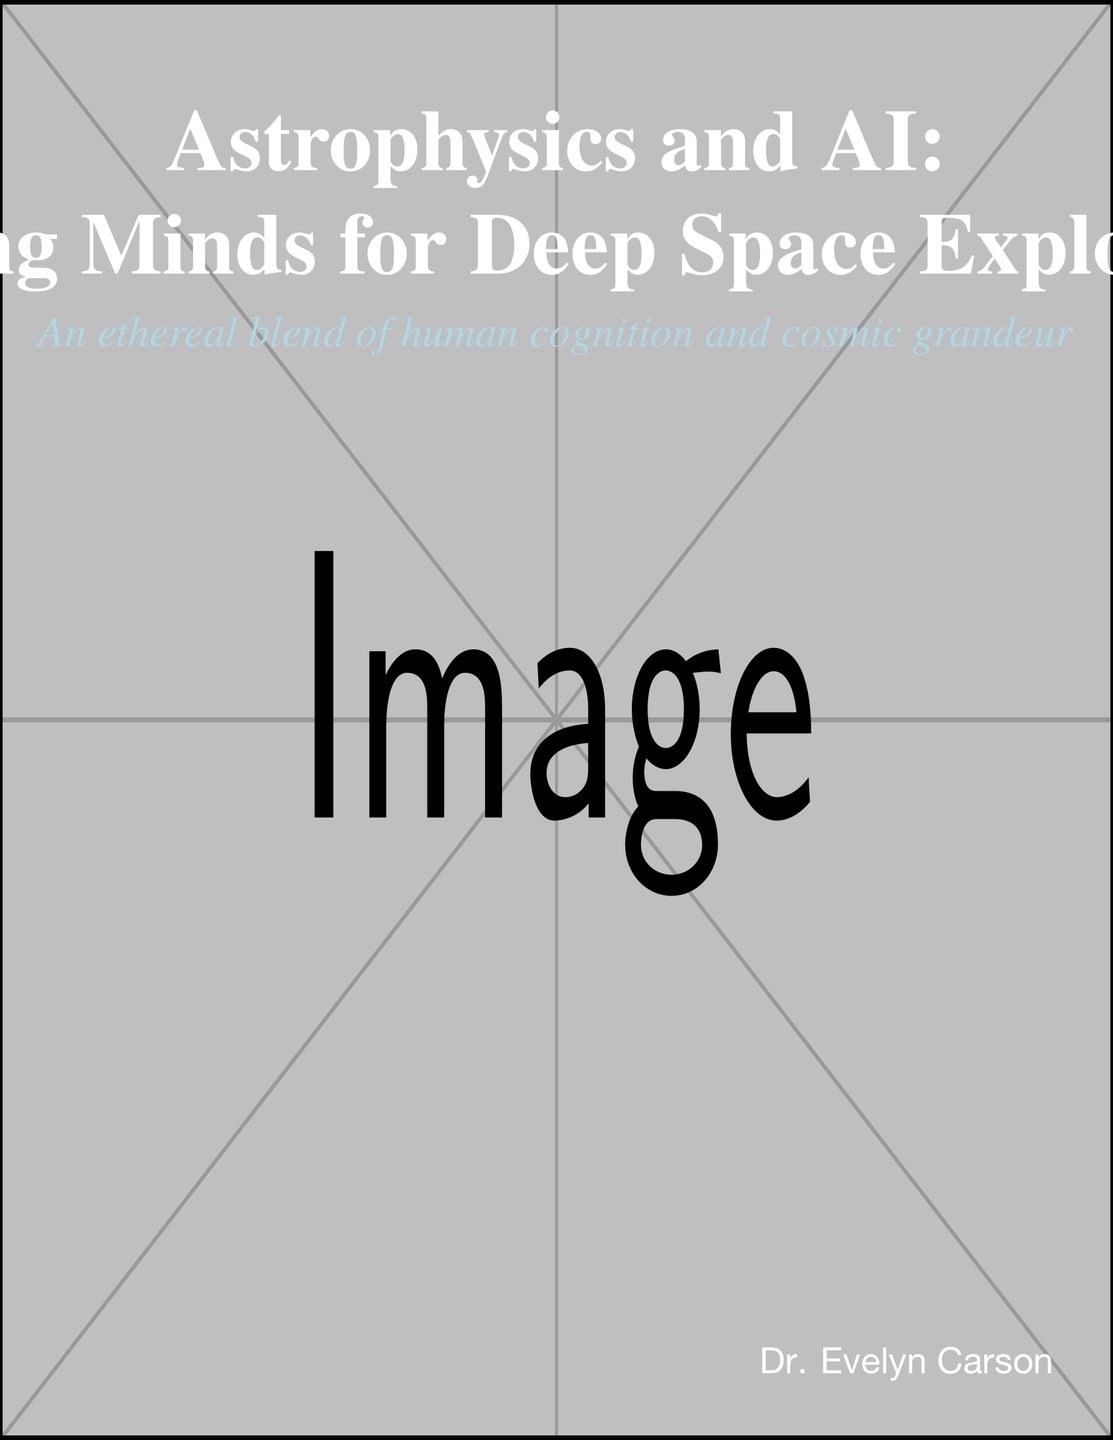What is the title of the book? The title is prominently displayed on the cover in large font.
Answer: Astrophysics and AI: Melding Minds for Deep Space Exploration Who is the author of the book? The author's name is located at the bottom right corner of the cover.
Answer: Dr. Evelyn Carson What color is the background of the book cover? The background color is specified in the document.
Answer: Nebula What type of imagery is merged with the human brain on the cover? The cover features an ethereal blend with cosmic elements.
Answer: Nebula What additional element is intertwined with the galactic structures? The visual representation includes other thematic digital elements.
Answer: Binary code What is the font color of the subtitle? The font color is indicated for the subtitle in the design.
Answer: Light blue What overall theme does the book cover convey? The overall theme can be inferred from the combination of elements depicted.
Answer: Cosmic grandeur and cognition What document type is represented by this cover? The context of the visual elements indicates a specific published format.
Answer: Book cover 